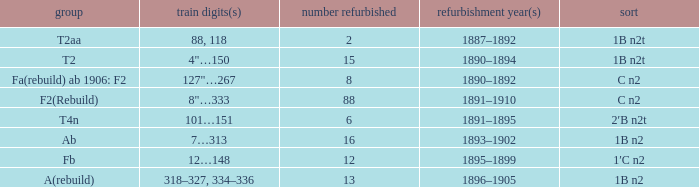What is the type if quantity rebuilt is more than 2 and the railway number is 4"…150? 1B n2t. 